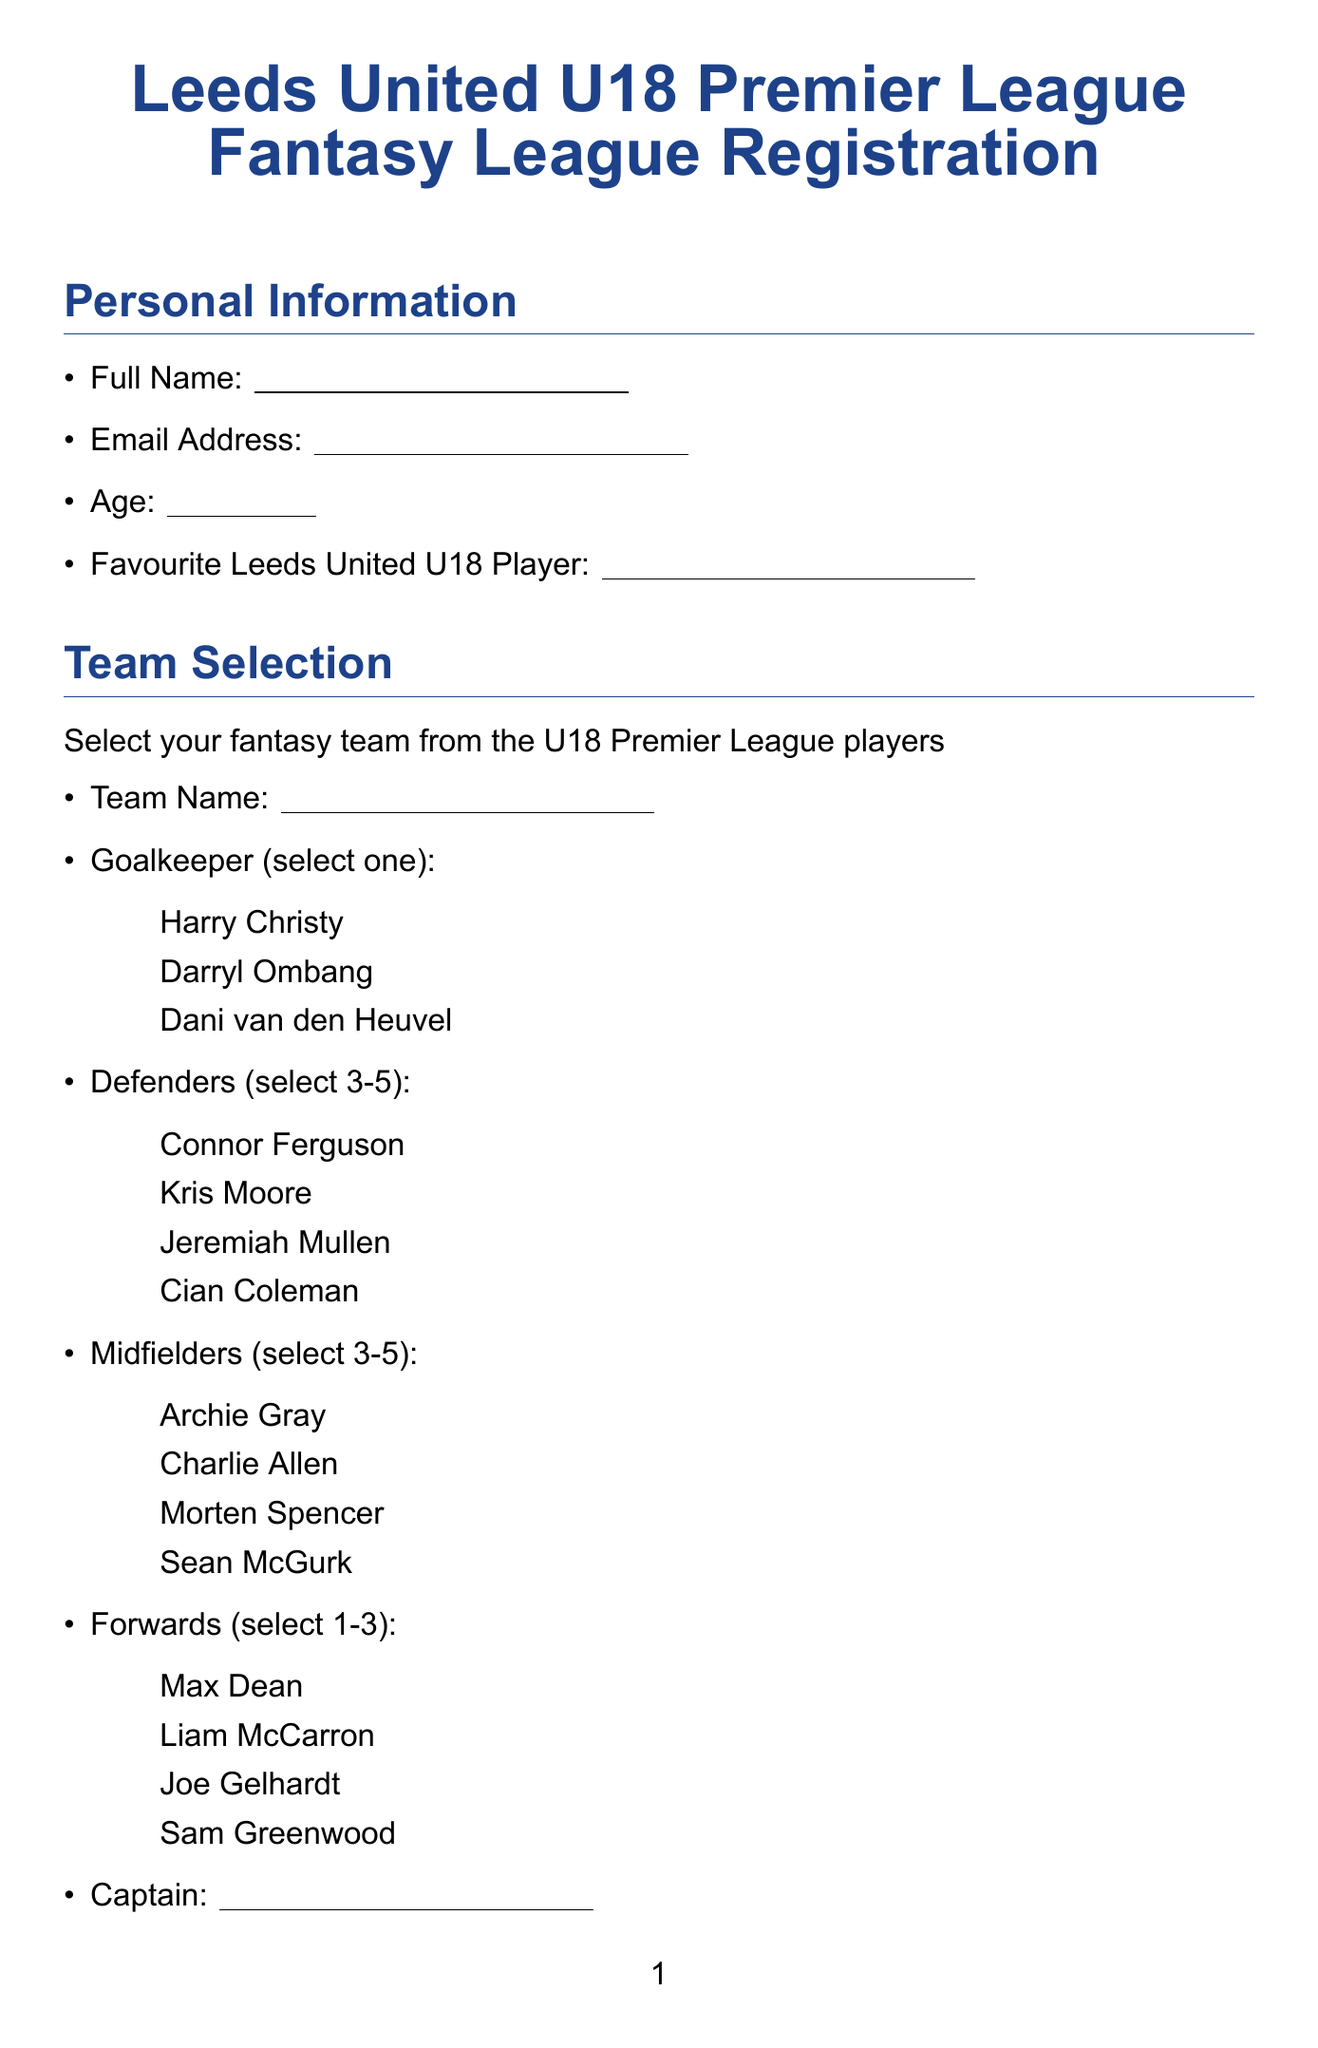What is the title of the form? The title is stated clearly at the top of the document, as "Leeds United U18 Premier League Fantasy League Registration."
Answer: Leeds United U18 Premier League Fantasy League Registration How many defenders must be selected? The document specifies that you must select a minimum of 3 and a maximum of 5 defenders for your team.
Answer: 3 to 5 What is the points value for an assist? The scoring system detailed in the document outlines specific points values for different actions, with assists being worth 3 points.
Answer: 3 Who is one of the options for goalkeeper? The options for goalkeeper are provided, including Harry Christy, which is one of the selections mentioned.
Answer: Harry Christy What is the penalty for additional transfers? The document states that additional transfers incur a penalty of -4 points.
Answer: -4 points How did the person hear about the fantasy league? The options provided include several ways someone might hear about the league, such as "Club Website," indicating how they learned about it.
Answer: Club Website What must be done before the fixture deadline? According to the league rules, team changes must be made before the U18 Premier League North fixture deadline each week.
Answer: Team changes Is it possible to receive updates about Leeds United U18 matches? The document allows the participant to opt-in to receive updates about matches, indicated by a checkbox option provided.
Answer: Yes What is the required age field type? The document specifies the type of entry needed for age, indicating that it must be a numerical input.
Answer: Number 